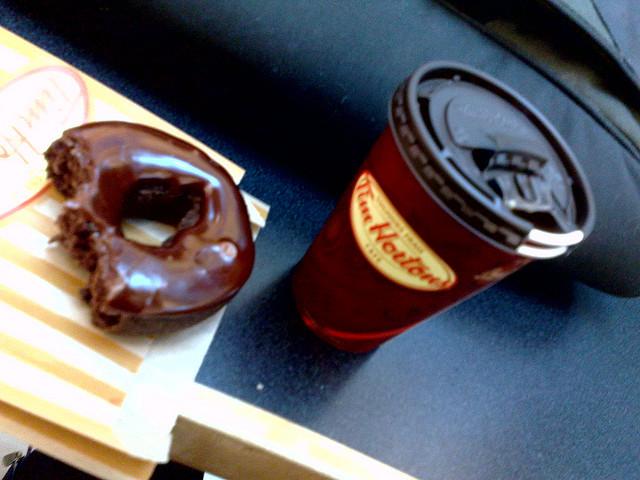What kind of drink is that?
Write a very short answer. Coffee. Is this a typical breakfast?
Concise answer only. Yes. Does this donut have a bite taken out?
Answer briefly. Yes. Was this photo snapped by a tall or short person?
Quick response, please. Tall. Where was the coffee purchased from?
Answer briefly. Tim hortons. 